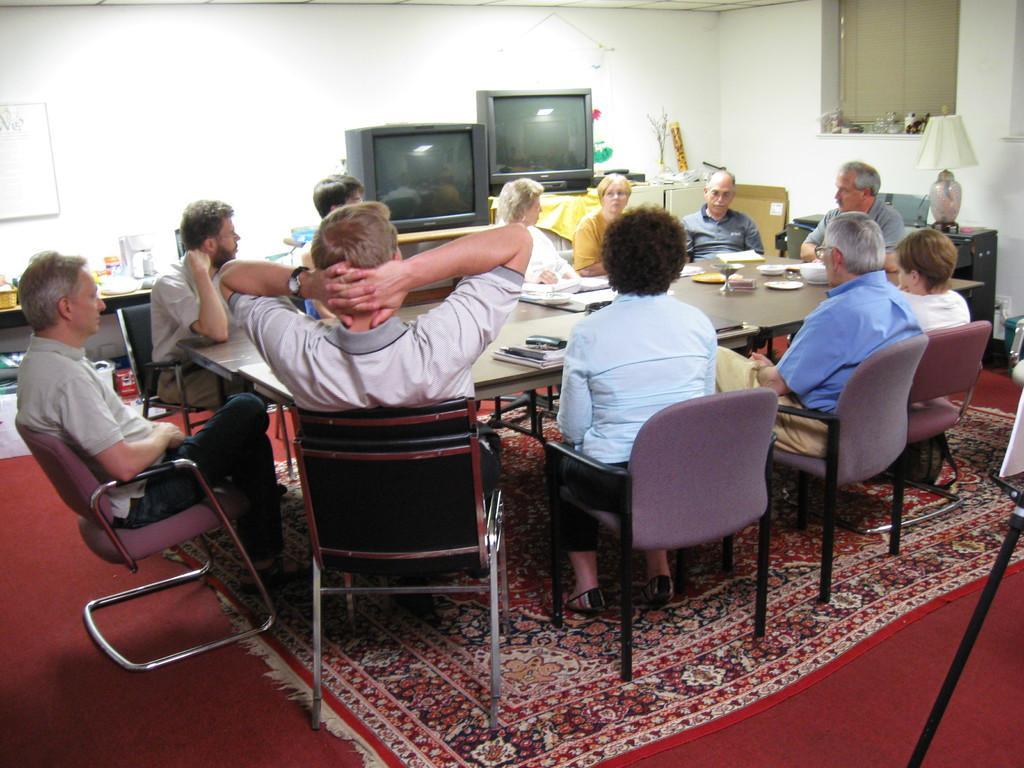In one or two sentences, can you explain what this image depicts? In this picture we can see some persons are sitting on the chairs. This is floor. There is a table. On the table there are books and plates. On the background there is a wall and there are televisions. And this is lamp. 